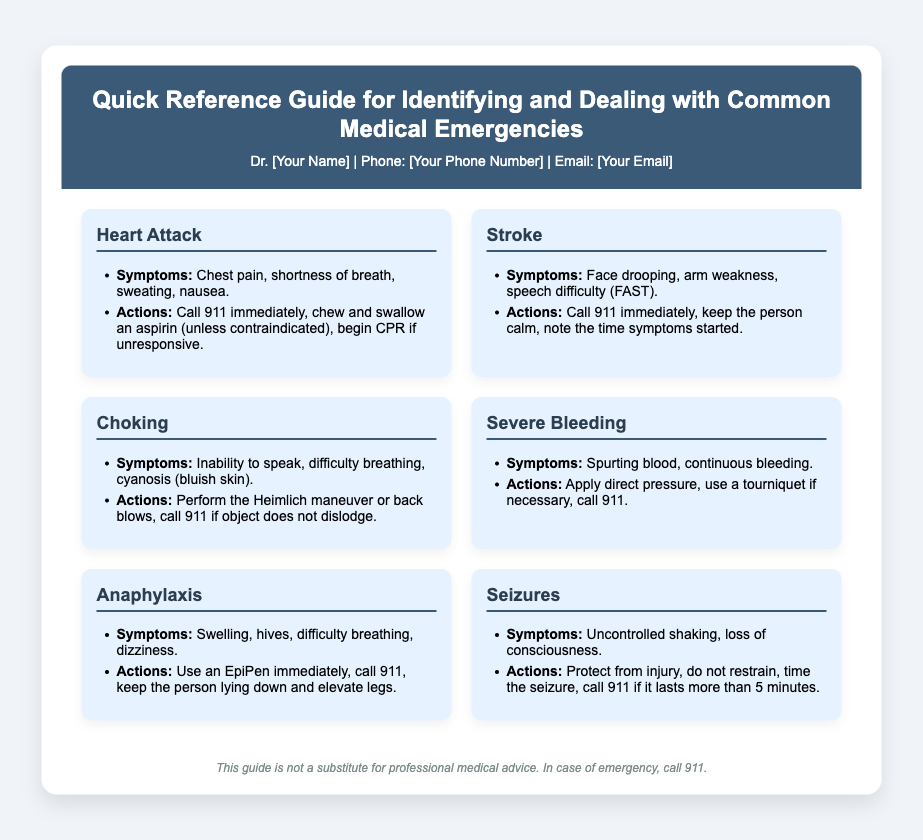what is the title of the guide? The title is stated clearly at the top of the document.
Answer: Quick Reference Guide for Identifying and Dealing with Common Medical Emergencies who is the contact person listed? The contact person is mentioned in the contact information section.
Answer: Dr. [Your Name] what should you do if someone is having a heart attack? The actions for a heart attack are outlined in the respective section of the document.
Answer: Call 911 immediately, chew and swallow an aspirin, begin CPR if unresponsive what symptoms indicate a stroke? The symptoms for a stroke are listed in the document.
Answer: Face drooping, arm weakness, speech difficulty (FAST) how should you respond to severe bleeding? The actions necessary for severe bleeding are described under that section.
Answer: Apply direct pressure, use a tourniquet if necessary, call 911 what is the first action for someone experiencing anaphylaxis? The document specifies the first action for handling anaphylaxis symptoms.
Answer: Use an EpiPen immediately what time duration for seizures warrants a call to 911? The document provides a specific time that indicates when to call for help during seizures.
Answer: More than 5 minutes what is a common symptom of choking? A specific symptom of choking is identified in the related section.
Answer: Inability to speak why is the disclaimer included in the document? The disclaimer provides important information about the limitations of the guide.
Answer: It's not a substitute for professional medical advice 